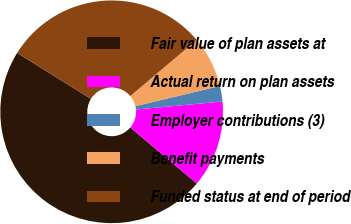Convert chart. <chart><loc_0><loc_0><loc_500><loc_500><pie_chart><fcel>Fair value of plan assets at<fcel>Actual return on plan assets<fcel>Employer contributions (3)<fcel>Benefit payments<fcel>Funded status at end of period<nl><fcel>47.72%<fcel>12.62%<fcel>2.25%<fcel>7.44%<fcel>29.97%<nl></chart> 